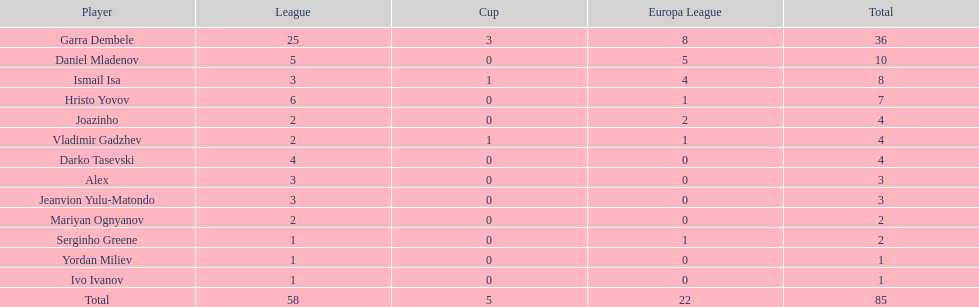Which participants only managed to score one goal? Serginho Greene, Yordan Miliev, Ivo Ivanov. 